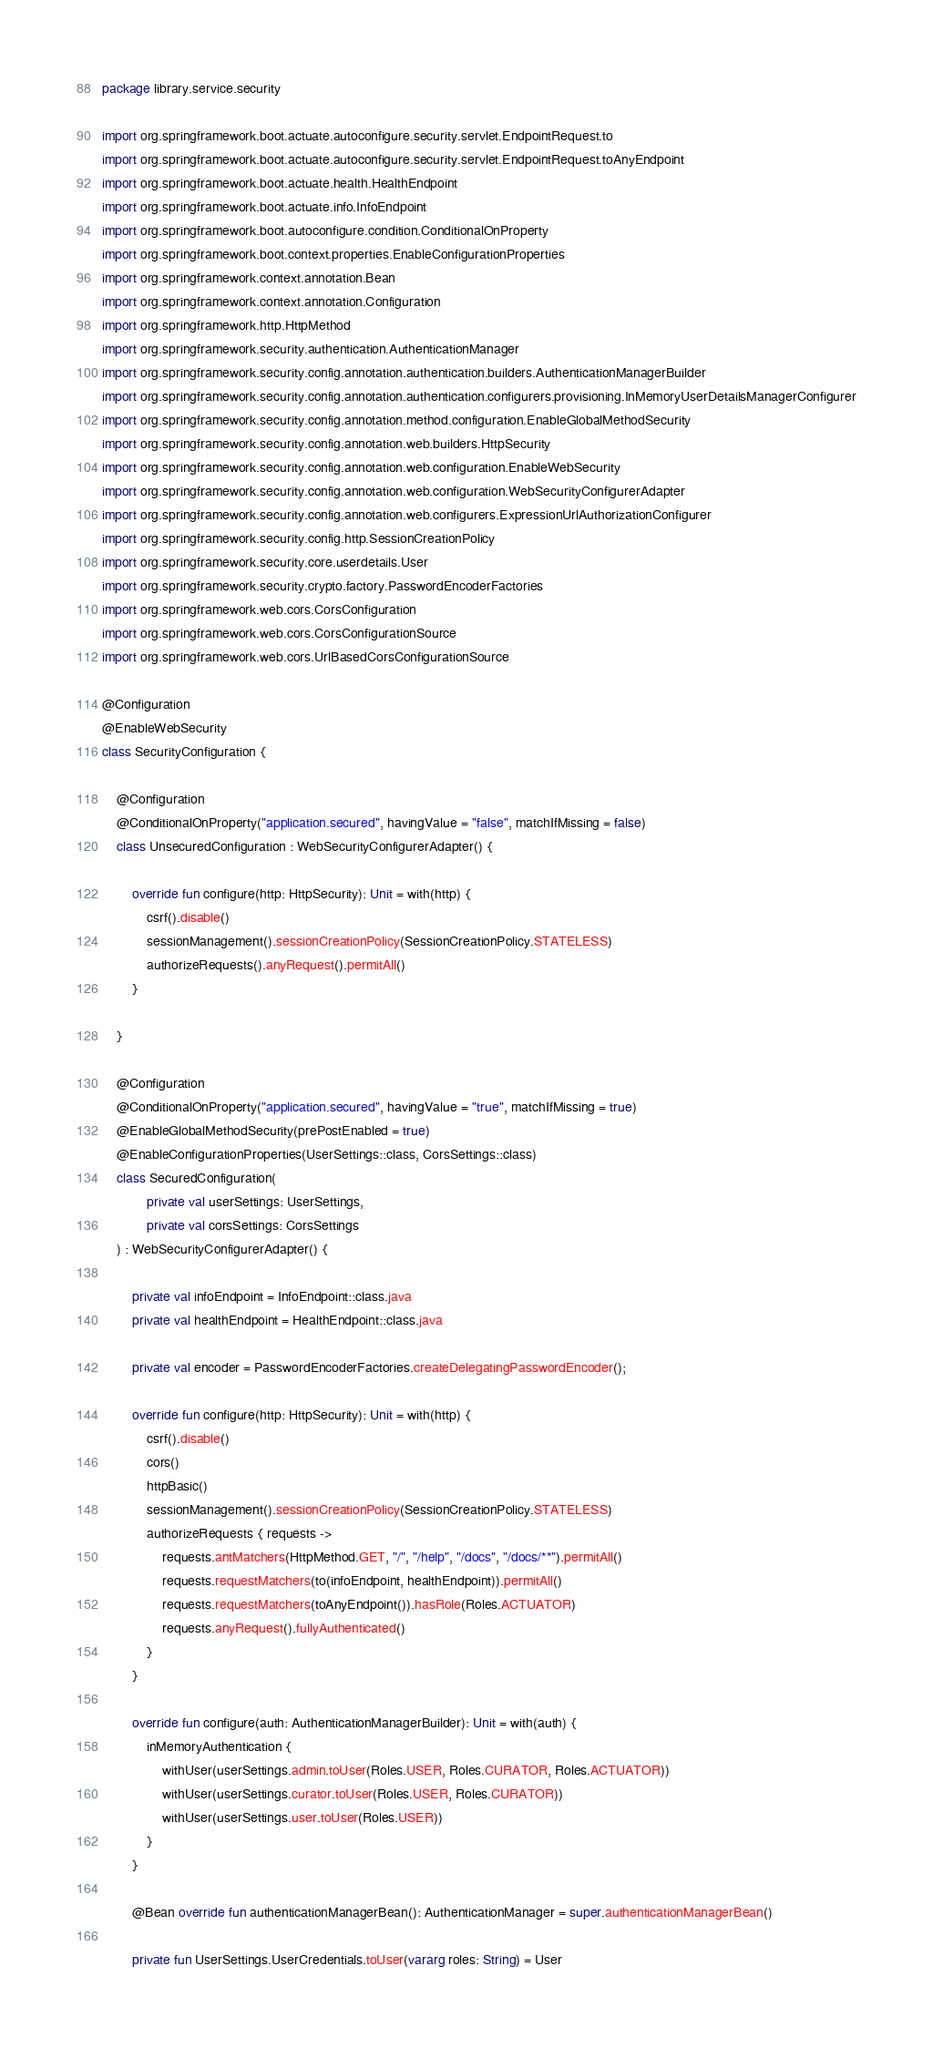Convert code to text. <code><loc_0><loc_0><loc_500><loc_500><_Kotlin_>package library.service.security

import org.springframework.boot.actuate.autoconfigure.security.servlet.EndpointRequest.to
import org.springframework.boot.actuate.autoconfigure.security.servlet.EndpointRequest.toAnyEndpoint
import org.springframework.boot.actuate.health.HealthEndpoint
import org.springframework.boot.actuate.info.InfoEndpoint
import org.springframework.boot.autoconfigure.condition.ConditionalOnProperty
import org.springframework.boot.context.properties.EnableConfigurationProperties
import org.springframework.context.annotation.Bean
import org.springframework.context.annotation.Configuration
import org.springframework.http.HttpMethod
import org.springframework.security.authentication.AuthenticationManager
import org.springframework.security.config.annotation.authentication.builders.AuthenticationManagerBuilder
import org.springframework.security.config.annotation.authentication.configurers.provisioning.InMemoryUserDetailsManagerConfigurer
import org.springframework.security.config.annotation.method.configuration.EnableGlobalMethodSecurity
import org.springframework.security.config.annotation.web.builders.HttpSecurity
import org.springframework.security.config.annotation.web.configuration.EnableWebSecurity
import org.springframework.security.config.annotation.web.configuration.WebSecurityConfigurerAdapter
import org.springframework.security.config.annotation.web.configurers.ExpressionUrlAuthorizationConfigurer
import org.springframework.security.config.http.SessionCreationPolicy
import org.springframework.security.core.userdetails.User
import org.springframework.security.crypto.factory.PasswordEncoderFactories
import org.springframework.web.cors.CorsConfiguration
import org.springframework.web.cors.CorsConfigurationSource
import org.springframework.web.cors.UrlBasedCorsConfigurationSource

@Configuration
@EnableWebSecurity
class SecurityConfiguration {

    @Configuration
    @ConditionalOnProperty("application.secured", havingValue = "false", matchIfMissing = false)
    class UnsecuredConfiguration : WebSecurityConfigurerAdapter() {

        override fun configure(http: HttpSecurity): Unit = with(http) {
            csrf().disable()
            sessionManagement().sessionCreationPolicy(SessionCreationPolicy.STATELESS)
            authorizeRequests().anyRequest().permitAll()
        }

    }

    @Configuration
    @ConditionalOnProperty("application.secured", havingValue = "true", matchIfMissing = true)
    @EnableGlobalMethodSecurity(prePostEnabled = true)
    @EnableConfigurationProperties(UserSettings::class, CorsSettings::class)
    class SecuredConfiguration(
            private val userSettings: UserSettings,
            private val corsSettings: CorsSettings
    ) : WebSecurityConfigurerAdapter() {

        private val infoEndpoint = InfoEndpoint::class.java
        private val healthEndpoint = HealthEndpoint::class.java

        private val encoder = PasswordEncoderFactories.createDelegatingPasswordEncoder();

        override fun configure(http: HttpSecurity): Unit = with(http) {
            csrf().disable()
            cors()
            httpBasic()
            sessionManagement().sessionCreationPolicy(SessionCreationPolicy.STATELESS)
            authorizeRequests { requests ->
                requests.antMatchers(HttpMethod.GET, "/", "/help", "/docs", "/docs/**").permitAll()
                requests.requestMatchers(to(infoEndpoint, healthEndpoint)).permitAll()
                requests.requestMatchers(toAnyEndpoint()).hasRole(Roles.ACTUATOR)
                requests.anyRequest().fullyAuthenticated()
            }
        }

        override fun configure(auth: AuthenticationManagerBuilder): Unit = with(auth) {
            inMemoryAuthentication {
                withUser(userSettings.admin.toUser(Roles.USER, Roles.CURATOR, Roles.ACTUATOR))
                withUser(userSettings.curator.toUser(Roles.USER, Roles.CURATOR))
                withUser(userSettings.user.toUser(Roles.USER))
            }
        }

        @Bean override fun authenticationManagerBean(): AuthenticationManager = super.authenticationManagerBean()

        private fun UserSettings.UserCredentials.toUser(vararg roles: String) = User</code> 